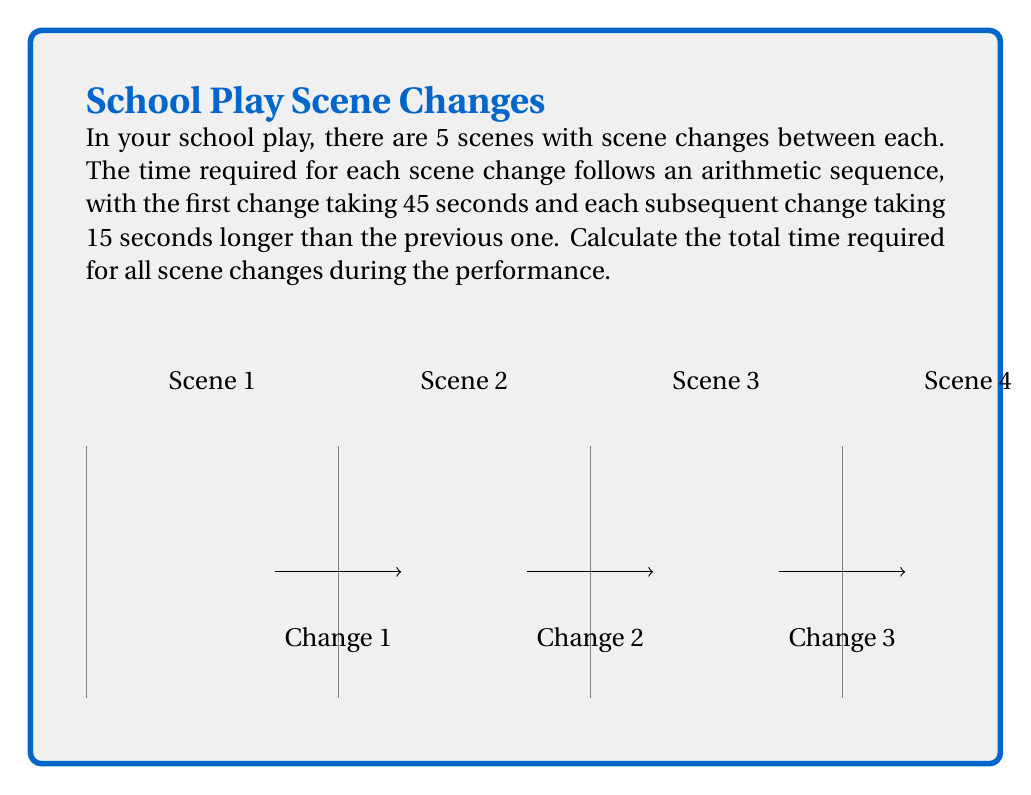Solve this math problem. Let's approach this step-by-step:

1) We have an arithmetic sequence for the scene change times. Let's define:
   $a_1 = 45$ (first term)
   $d = 15$ (common difference)
   $n = 4$ (number of terms, as there are 4 scene changes for 5 scenes)

2) The formula for the nth term of an arithmetic sequence is:
   $a_n = a_1 + (n-1)d$

3) We need to find the sum of all terms. The formula for the sum of an arithmetic sequence is:
   $S_n = \frac{n}{2}(a_1 + a_n)$

4) First, let's find $a_n$:
   $a_4 = 45 + (4-1)15 = 45 + 45 = 90$

5) Now we can apply the sum formula:
   $S_4 = \frac{4}{2}(45 + 90) = 2(135) = 270$

Therefore, the total time for all scene changes is 270 seconds.
Answer: 270 seconds 